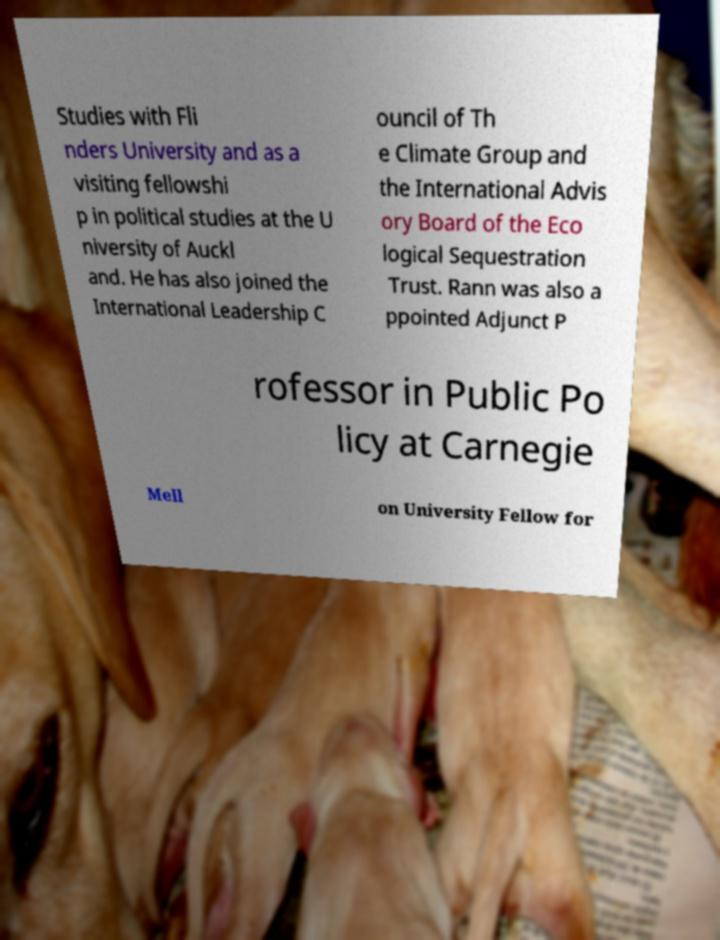There's text embedded in this image that I need extracted. Can you transcribe it verbatim? Studies with Fli nders University and as a visiting fellowshi p in political studies at the U niversity of Auckl and. He has also joined the International Leadership C ouncil of Th e Climate Group and the International Advis ory Board of the Eco logical Sequestration Trust. Rann was also a ppointed Adjunct P rofessor in Public Po licy at Carnegie Mell on University Fellow for 